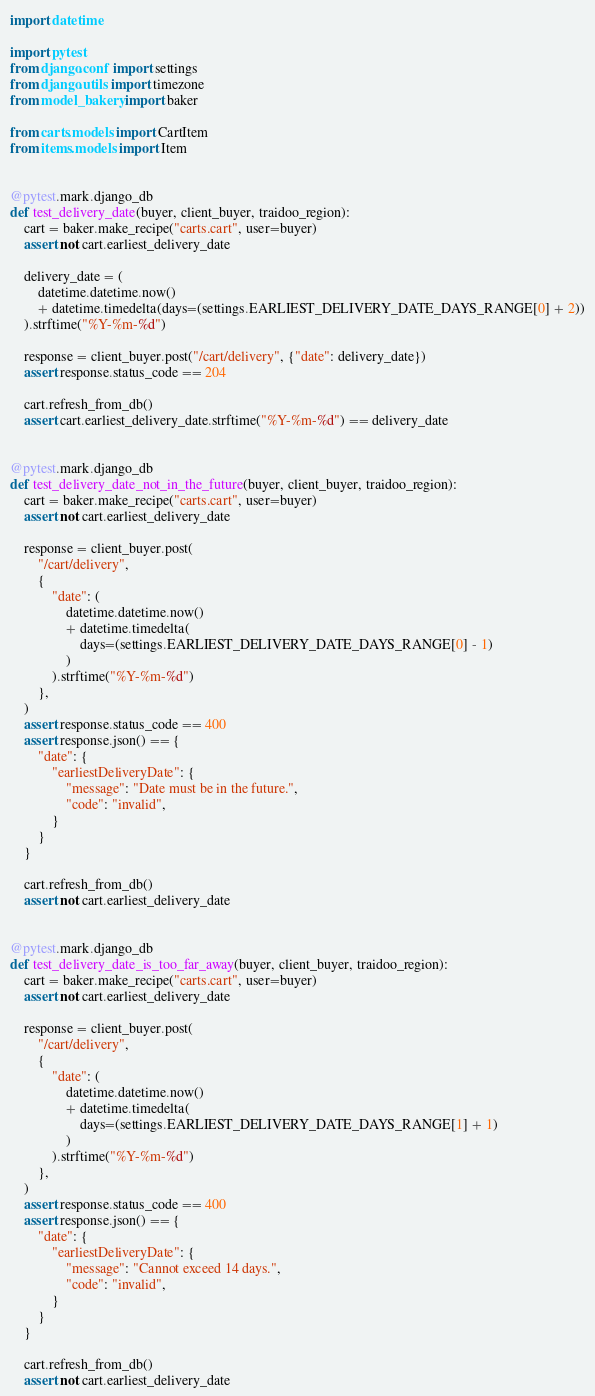Convert code to text. <code><loc_0><loc_0><loc_500><loc_500><_Python_>import datetime

import pytest
from django.conf import settings
from django.utils import timezone
from model_bakery import baker

from carts.models import CartItem
from items.models import Item


@pytest.mark.django_db
def test_delivery_date(buyer, client_buyer, traidoo_region):
    cart = baker.make_recipe("carts.cart", user=buyer)
    assert not cart.earliest_delivery_date

    delivery_date = (
        datetime.datetime.now()
        + datetime.timedelta(days=(settings.EARLIEST_DELIVERY_DATE_DAYS_RANGE[0] + 2))
    ).strftime("%Y-%m-%d")

    response = client_buyer.post("/cart/delivery", {"date": delivery_date})
    assert response.status_code == 204

    cart.refresh_from_db()
    assert cart.earliest_delivery_date.strftime("%Y-%m-%d") == delivery_date


@pytest.mark.django_db
def test_delivery_date_not_in_the_future(buyer, client_buyer, traidoo_region):
    cart = baker.make_recipe("carts.cart", user=buyer)
    assert not cart.earliest_delivery_date

    response = client_buyer.post(
        "/cart/delivery",
        {
            "date": (
                datetime.datetime.now()
                + datetime.timedelta(
                    days=(settings.EARLIEST_DELIVERY_DATE_DAYS_RANGE[0] - 1)
                )
            ).strftime("%Y-%m-%d")
        },
    )
    assert response.status_code == 400
    assert response.json() == {
        "date": {
            "earliestDeliveryDate": {
                "message": "Date must be in the future.",
                "code": "invalid",
            }
        }
    }

    cart.refresh_from_db()
    assert not cart.earliest_delivery_date


@pytest.mark.django_db
def test_delivery_date_is_too_far_away(buyer, client_buyer, traidoo_region):
    cart = baker.make_recipe("carts.cart", user=buyer)
    assert not cart.earliest_delivery_date

    response = client_buyer.post(
        "/cart/delivery",
        {
            "date": (
                datetime.datetime.now()
                + datetime.timedelta(
                    days=(settings.EARLIEST_DELIVERY_DATE_DAYS_RANGE[1] + 1)
                )
            ).strftime("%Y-%m-%d")
        },
    )
    assert response.status_code == 400
    assert response.json() == {
        "date": {
            "earliestDeliveryDate": {
                "message": "Cannot exceed 14 days.",
                "code": "invalid",
            }
        }
    }

    cart.refresh_from_db()
    assert not cart.earliest_delivery_date
</code> 